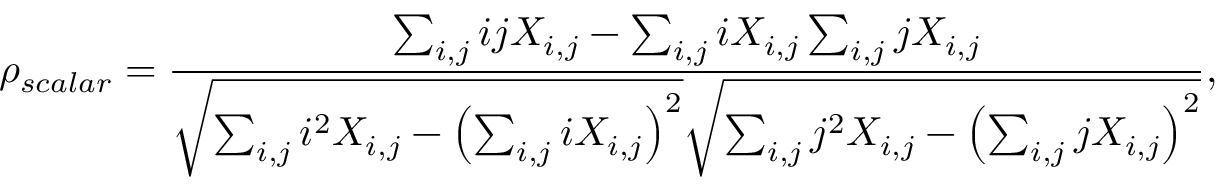<formula> <loc_0><loc_0><loc_500><loc_500>\rho _ { s c a l a r } = \frac { \sum _ { i , j } i j X _ { i , j } - \sum _ { i , j } i X _ { i , j } \sum _ { i , j } j X _ { i , j } } { \sqrt { \sum _ { i , j } i ^ { 2 } X _ { i , j } - \left ( \sum _ { i , j } i X _ { i , j } \right ) ^ { 2 } } \sqrt { \sum _ { i , j } j ^ { 2 } X _ { i , j } - \left ( \sum _ { i , j } j X _ { i , j } \right ) ^ { 2 } } } ,</formula> 